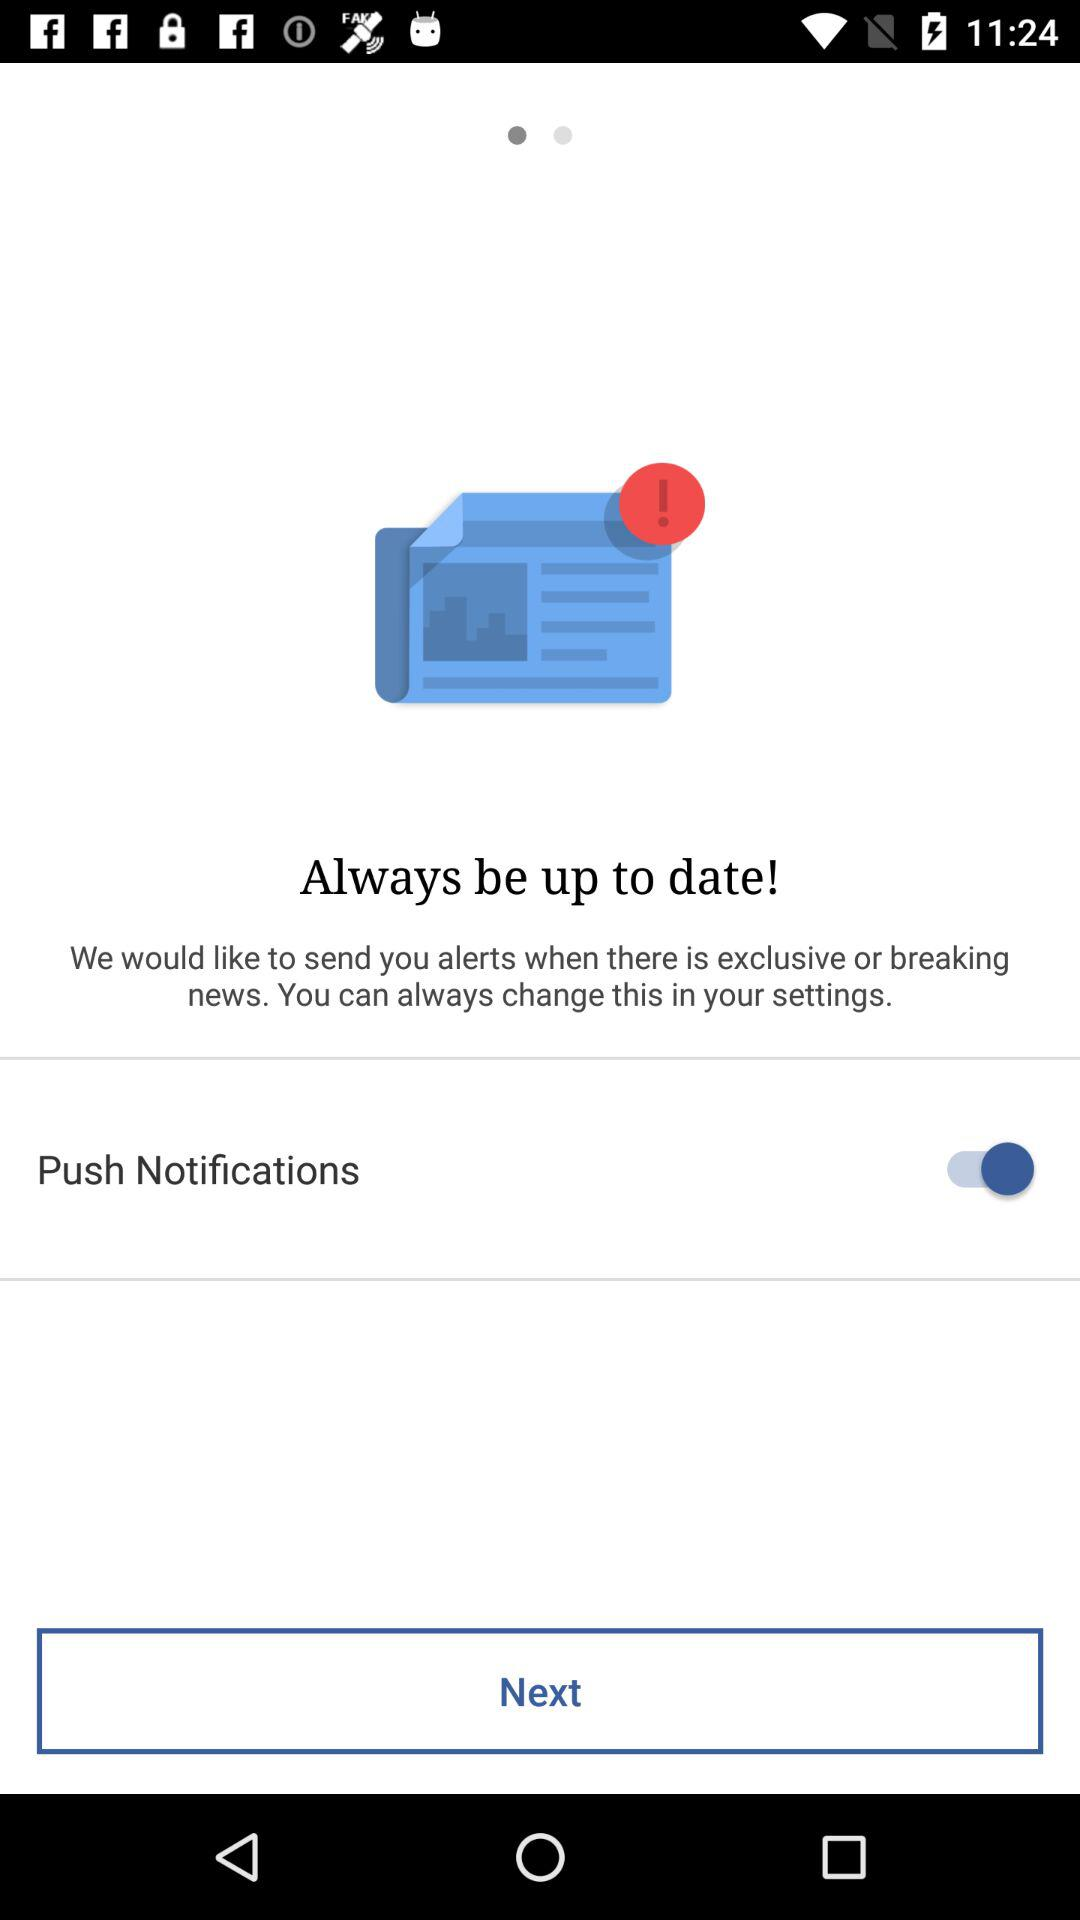What is the status of the "Push Notifications"? The status is "on". 